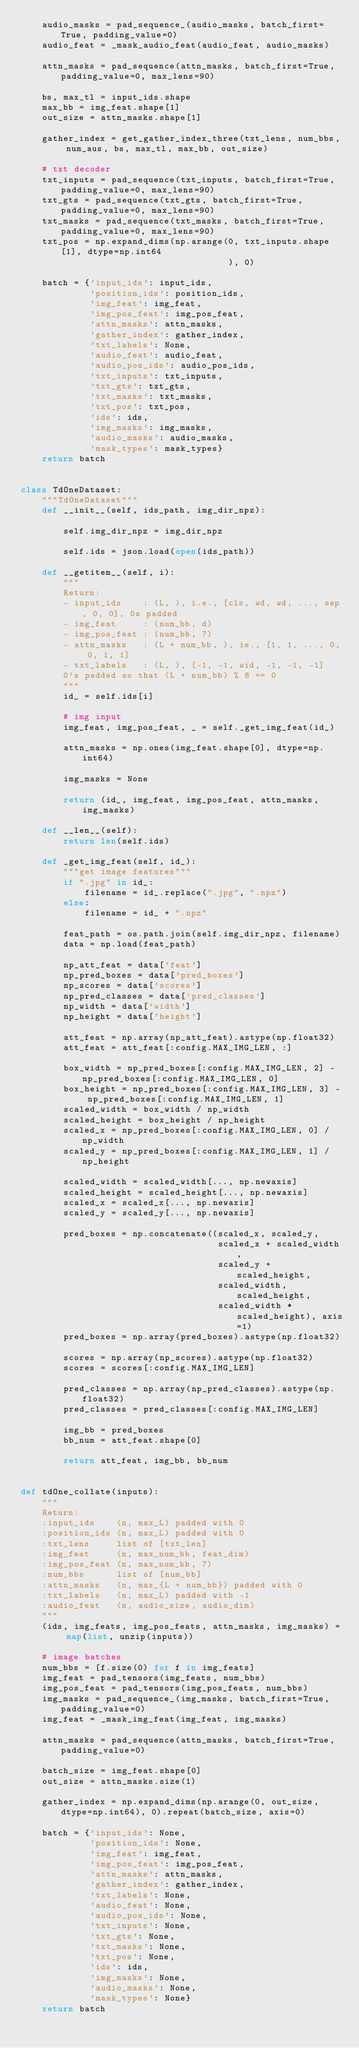<code> <loc_0><loc_0><loc_500><loc_500><_Python_>    audio_masks = pad_sequence_(audio_masks, batch_first=True, padding_value=0)
    audio_feat = _mask_audio_feat(audio_feat, audio_masks)

    attn_masks = pad_sequence(attn_masks, batch_first=True, padding_value=0, max_lens=90)

    bs, max_tl = input_ids.shape
    max_bb = img_feat.shape[1]
    out_size = attn_masks.shape[1]

    gather_index = get_gather_index_three(txt_lens, num_bbs, num_aus, bs, max_tl, max_bb, out_size)

    # txt decoder
    txt_inputs = pad_sequence(txt_inputs, batch_first=True, padding_value=0, max_lens=90)
    txt_gts = pad_sequence(txt_gts, batch_first=True, padding_value=0, max_lens=90)
    txt_masks = pad_sequence(txt_masks, batch_first=True, padding_value=0, max_lens=90)
    txt_pos = np.expand_dims(np.arange(0, txt_inputs.shape[1], dtype=np.int64
                                       ), 0)

    batch = {'input_ids': input_ids,
             'position_ids': position_ids,
             'img_feat': img_feat,
             'img_pos_feat': img_pos_feat,
             'attn_masks': attn_masks,
             'gather_index': gather_index,
             'txt_labels': None,
             'audio_feat': audio_feat,
             'audio_pos_ids': audio_pos_ids,
             'txt_inputs': txt_inputs,
             'txt_gts': txt_gts,
             'txt_masks': txt_masks,
             'txt_pos': txt_pos,
             'ids': ids,
             'img_masks': img_masks,
             'audio_masks': audio_masks,
             'mask_types': mask_types}
    return batch


class TdOneDataset:
    """TdOneDataset"""
    def __init__(self, ids_path, img_dir_npz):

        self.img_dir_npz = img_dir_npz

        self.ids = json.load(open(ids_path))

    def __getitem__(self, i):
        """
        Return:
        - input_ids    : (L, ), i.e., [cls, wd, wd, ..., sep, 0, 0], 0s padded
        - img_feat     : (num_bb, d)
        - img_pos_feat : (num_bb, 7)
        - attn_masks   : (L + num_bb, ), ie., [1, 1, ..., 0, 0, 1, 1]
        - txt_labels   : (L, ), [-1, -1, wid, -1, -1, -1]
        0's padded so that (L + num_bb) % 8 == 0
        """
        id_ = self.ids[i]

        # img input
        img_feat, img_pos_feat, _ = self._get_img_feat(id_)

        attn_masks = np.ones(img_feat.shape[0], dtype=np.int64)

        img_masks = None

        return (id_, img_feat, img_pos_feat, attn_masks, img_masks)

    def __len__(self):
        return len(self.ids)

    def _get_img_feat(self, id_):
        """get image features"""
        if ".jpg" in id_:
            filename = id_.replace(".jpg", ".npz")
        else:
            filename = id_ + ".npz"

        feat_path = os.path.join(self.img_dir_npz, filename)
        data = np.load(feat_path)

        np_att_feat = data['feat']
        np_pred_boxes = data['pred_boxes']
        np_scores = data['scores']
        np_pred_classes = data['pred_classes']
        np_width = data['width']
        np_height = data['height']

        att_feat = np.array(np_att_feat).astype(np.float32)
        att_feat = att_feat[:config.MAX_IMG_LEN, :]

        box_width = np_pred_boxes[:config.MAX_IMG_LEN, 2] - np_pred_boxes[:config.MAX_IMG_LEN, 0]
        box_height = np_pred_boxes[:config.MAX_IMG_LEN, 3] - np_pred_boxes[:config.MAX_IMG_LEN, 1]
        scaled_width = box_width / np_width
        scaled_height = box_height / np_height
        scaled_x = np_pred_boxes[:config.MAX_IMG_LEN, 0] / np_width
        scaled_y = np_pred_boxes[:config.MAX_IMG_LEN, 1] / np_height

        scaled_width = scaled_width[..., np.newaxis]
        scaled_height = scaled_height[..., np.newaxis]
        scaled_x = scaled_x[..., np.newaxis]
        scaled_y = scaled_y[..., np.newaxis]

        pred_boxes = np.concatenate((scaled_x, scaled_y,
                                     scaled_x + scaled_width,
                                     scaled_y + scaled_height,
                                     scaled_width, scaled_height,
                                     scaled_width * scaled_height), axis=1)
        pred_boxes = np.array(pred_boxes).astype(np.float32)

        scores = np.array(np_scores).astype(np.float32)
        scores = scores[:config.MAX_IMG_LEN]

        pred_classes = np.array(np_pred_classes).astype(np.float32)
        pred_classes = pred_classes[:config.MAX_IMG_LEN]

        img_bb = pred_boxes
        bb_num = att_feat.shape[0]

        return att_feat, img_bb, bb_num


def tdOne_collate(inputs):
    """
    Return:
    :input_ids    (n, max_L) padded with 0
    :position_ids (n, max_L) padded with 0
    :txt_lens     list of [txt_len]
    :img_feat     (n, max_num_bb, feat_dim)
    :img_pos_feat (n, max_num_bb, 7)
    :num_bbs      list of [num_bb]
    :attn_masks   (n, max_{L + num_bb}) padded with 0
    :txt_labels   (n, max_L) padded with -1
    :audio_feat   (n, audio_size, audio_dim)
    """
    (ids, img_feats, img_pos_feats, attn_masks, img_masks) = map(list, unzip(inputs))

    # image batches
    num_bbs = [f.size(0) for f in img_feats]
    img_feat = pad_tensors(img_feats, num_bbs)
    img_pos_feat = pad_tensors(img_pos_feats, num_bbs)
    img_masks = pad_sequence_(img_masks, batch_first=True, padding_value=0)
    img_feat = _mask_img_feat(img_feat, img_masks)

    attn_masks = pad_sequence(attn_masks, batch_first=True, padding_value=0)

    batch_size = img_feat.shape[0]
    out_size = attn_masks.size(1)

    gather_index = np.expand_dims(np.arange(0, out_size, dtype=np.int64), 0).repeat(batch_size, axis=0)

    batch = {'input_ids': None,
             'position_ids': None,
             'img_feat': img_feat,
             'img_pos_feat': img_pos_feat,
             'attn_masks': attn_masks,
             'gather_index': gather_index,
             'txt_labels': None,
             'audio_feat': None,
             'audio_pos_ids': None,
             'txt_inputs': None,
             'txt_gts': None,
             'txt_masks': None,
             'txt_pos': None,
             'ids': ids,
             'img_masks': None,
             'audio_masks': None,
             'mask_types': None}
    return batch
</code> 